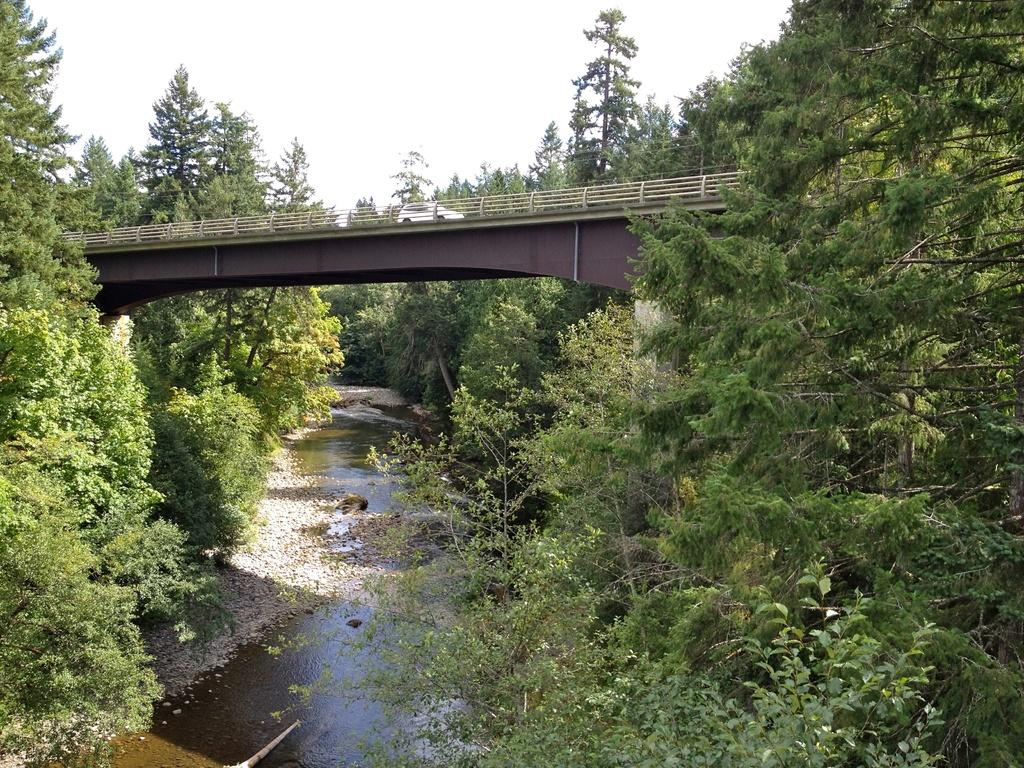What type of vegetation can be seen in the image? There are trees in the image. What natural element is visible in the image? There is water visible in the image. Where is the car located in the image? The car is on a bridge in the image. What is visible in the background of the image? The sky is visible in the background of the image. Can you see any fangs in the image? There are no fangs present in the image. What type of straw is being used to drink the water in the image? There is no straw visible in the image. 